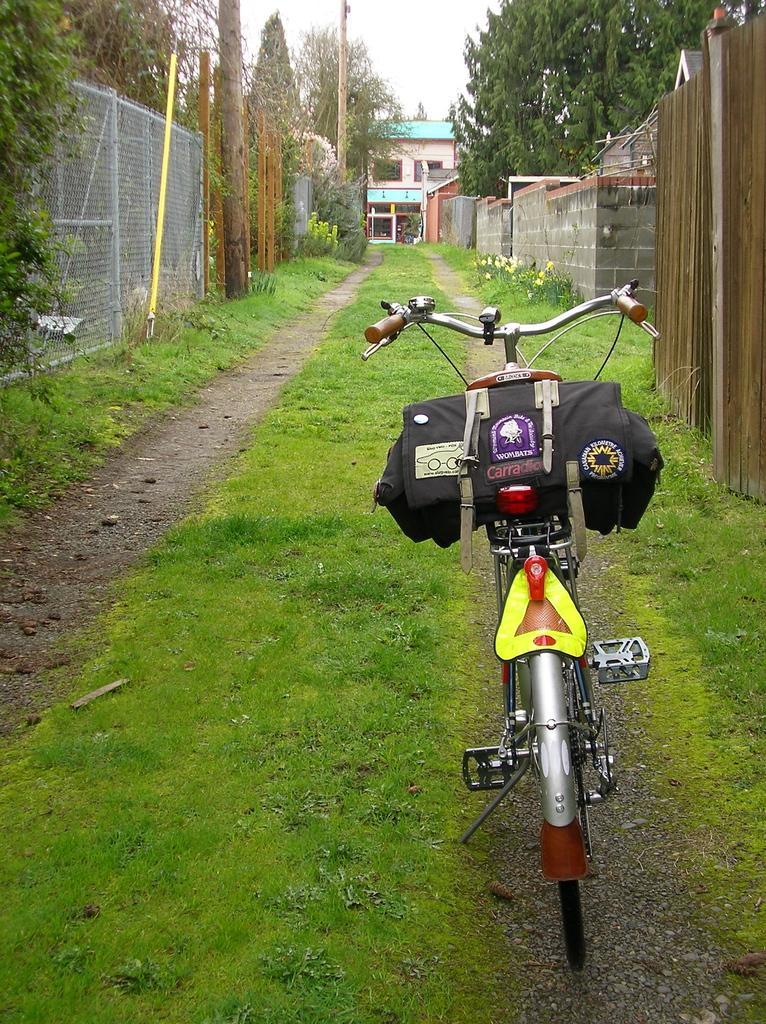Describe this image in one or two sentences. In the foreground of this image, there is a bicycle and a bag on it and there is also the grass on the both the sides to the path. On the right, there are plants, wall and a tree. On the left, there are trees and the fencing. In the background, there is a building and the sky. 